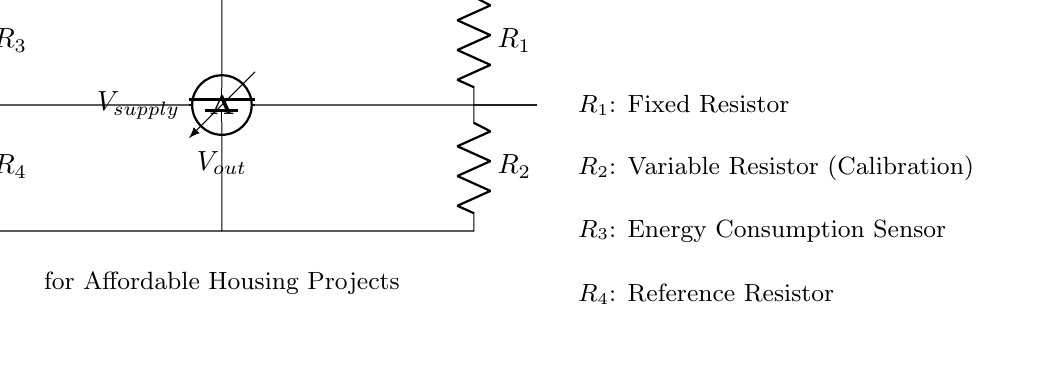What is the source voltage in the circuit? The source voltage is labeled as V_supply in the circuit diagram. It represents the voltage provided to the entire circuit from the battery.
Answer: V_supply How many resistors are present in the circuit? There are four resistors identified in the circuit: R_1, R_2, R_3, and R_4. These are indicated directly in the diagram.
Answer: Four What is the role of R_2 in the circuit? R_2 is labeled as a variable resistor for calibration. It suggests that its resistance can be adjusted to fine-tune the circuit's response during energy consumption monitoring.
Answer: Variable resistor (Calibration) Which resistor acts as a reference in the circuit? R_4 is explicitly designated as the reference resistor in the schematic, which typically serves to set a point of comparison in bridge circuits.
Answer: R_4 What is measured by the voltmeter in this bridge circuit? The voltmeter reads the output voltage, denoted as V_out, which reflects the voltage difference that arises due to the variation in resistance from the energy consumption sensor and the reference resistor.
Answer: V_out How does the bridge circuit help in monitoring energy consumption? The bridge circuit works by comparing the voltage drop across R_3 (energy consumption sensor) and R_4 (reference resistor). Any imbalance in these resistances leads to a measurable V_out, indicating energy consumption levels.
Answer: By comparing resistances What happens if R_1 and R_3 have equal values? When R_1 and R_3 are equal, it implies a balanced bridge condition where V_out equals zero, indicating no energy consumption is detected by the sensor. This status suggests that the consumption traits parallel each other.
Answer: V_out equals zero 